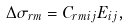Convert formula to latex. <formula><loc_0><loc_0><loc_500><loc_500>\Delta \sigma _ { r m } = C _ { r m i j } E _ { i j } ,</formula> 